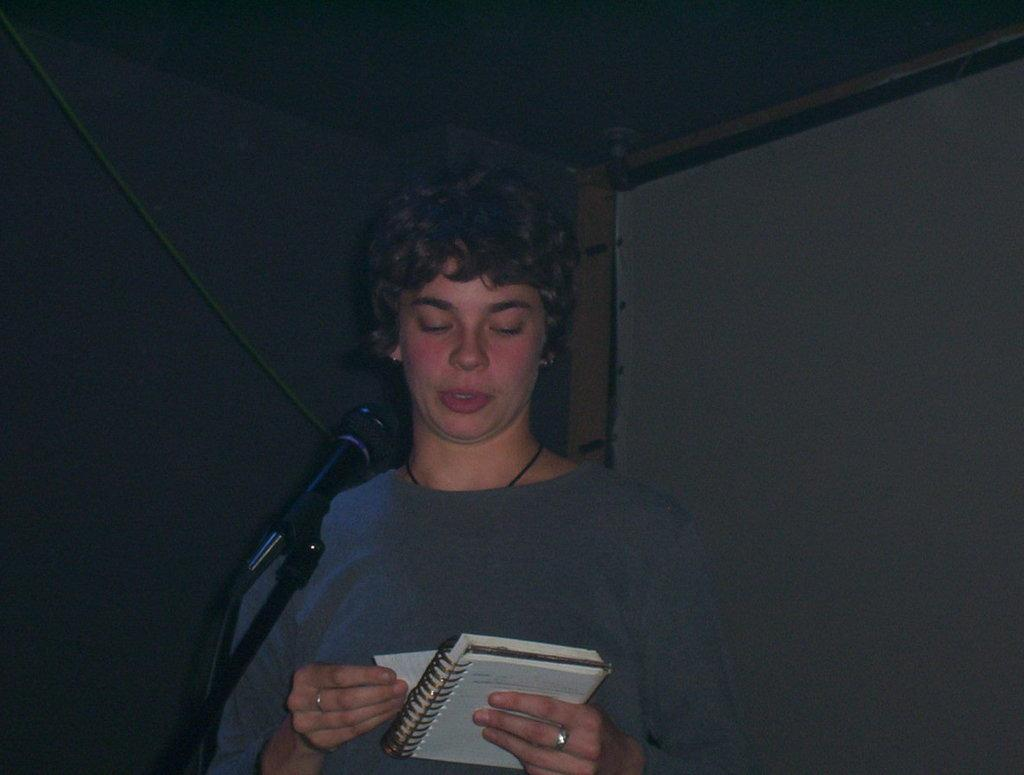Who is the main subject in the image? There is a boy in the image. What is the boy wearing? The boy is wearing a grey t-shirt. What object is the boy holding? The boy is holding a notebook. What activity is the boy engaged in? The boy is talking on a microphone. What can be seen on the wall in the background? There is a banner on the wall in the background. What type of branch can be seen in the boy's hand in the image? There is no branch present in the boy's hand in the image; he is holding a notebook. Does the boy have a pet with him in the image? There is no pet visible in the image; the boy is holding a notebook and talking on a microphone. 